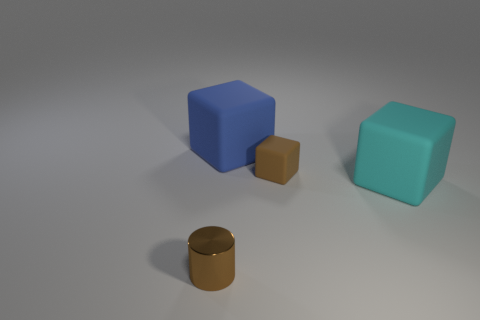Subtract all big cyan blocks. How many blocks are left? 2 Add 1 cyan rubber cubes. How many objects exist? 5 Subtract all cyan cubes. How many cubes are left? 2 Subtract all cylinders. How many objects are left? 3 Subtract all purple cubes. Subtract all brown cylinders. How many cubes are left? 3 Subtract all blue matte blocks. Subtract all gray spheres. How many objects are left? 3 Add 3 big blue things. How many big blue things are left? 4 Add 2 green rubber cubes. How many green rubber cubes exist? 2 Subtract 0 green cylinders. How many objects are left? 4 